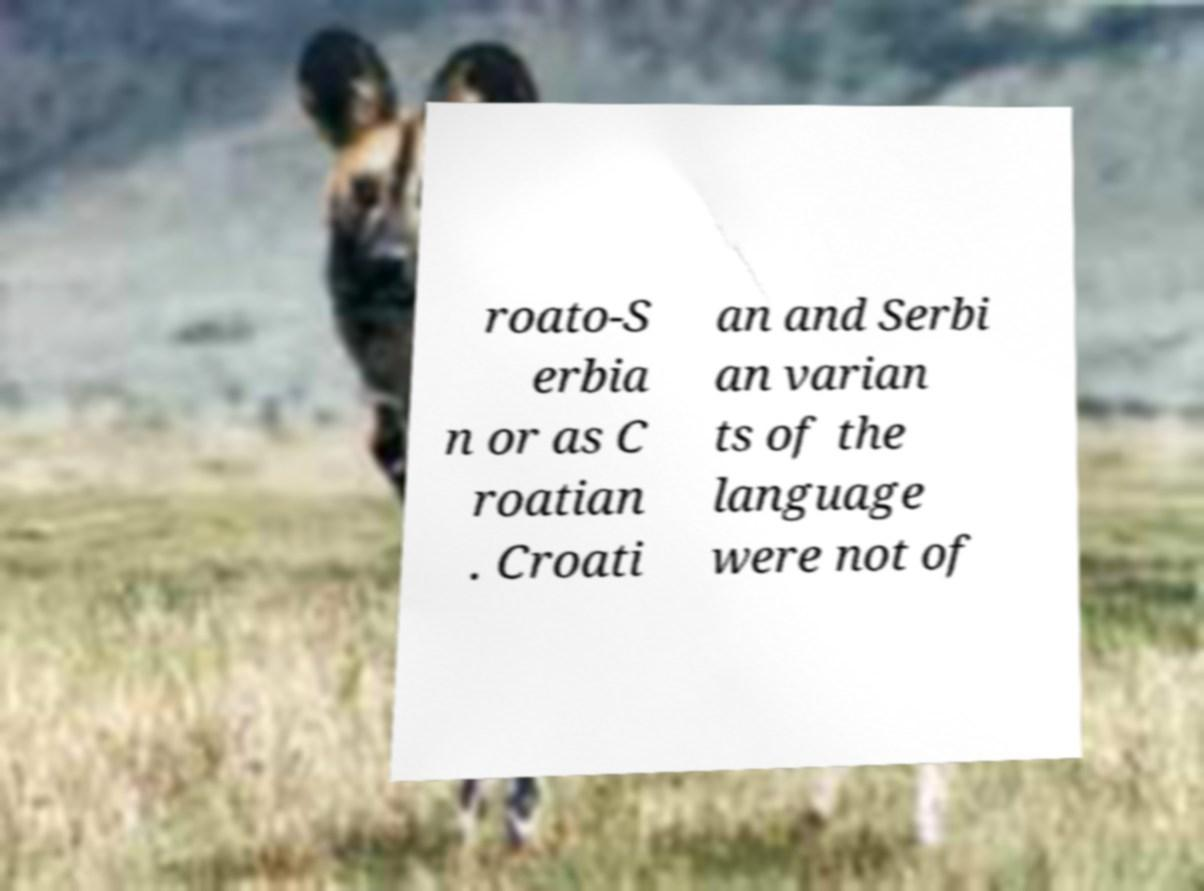There's text embedded in this image that I need extracted. Can you transcribe it verbatim? roato-S erbia n or as C roatian . Croati an and Serbi an varian ts of the language were not of 